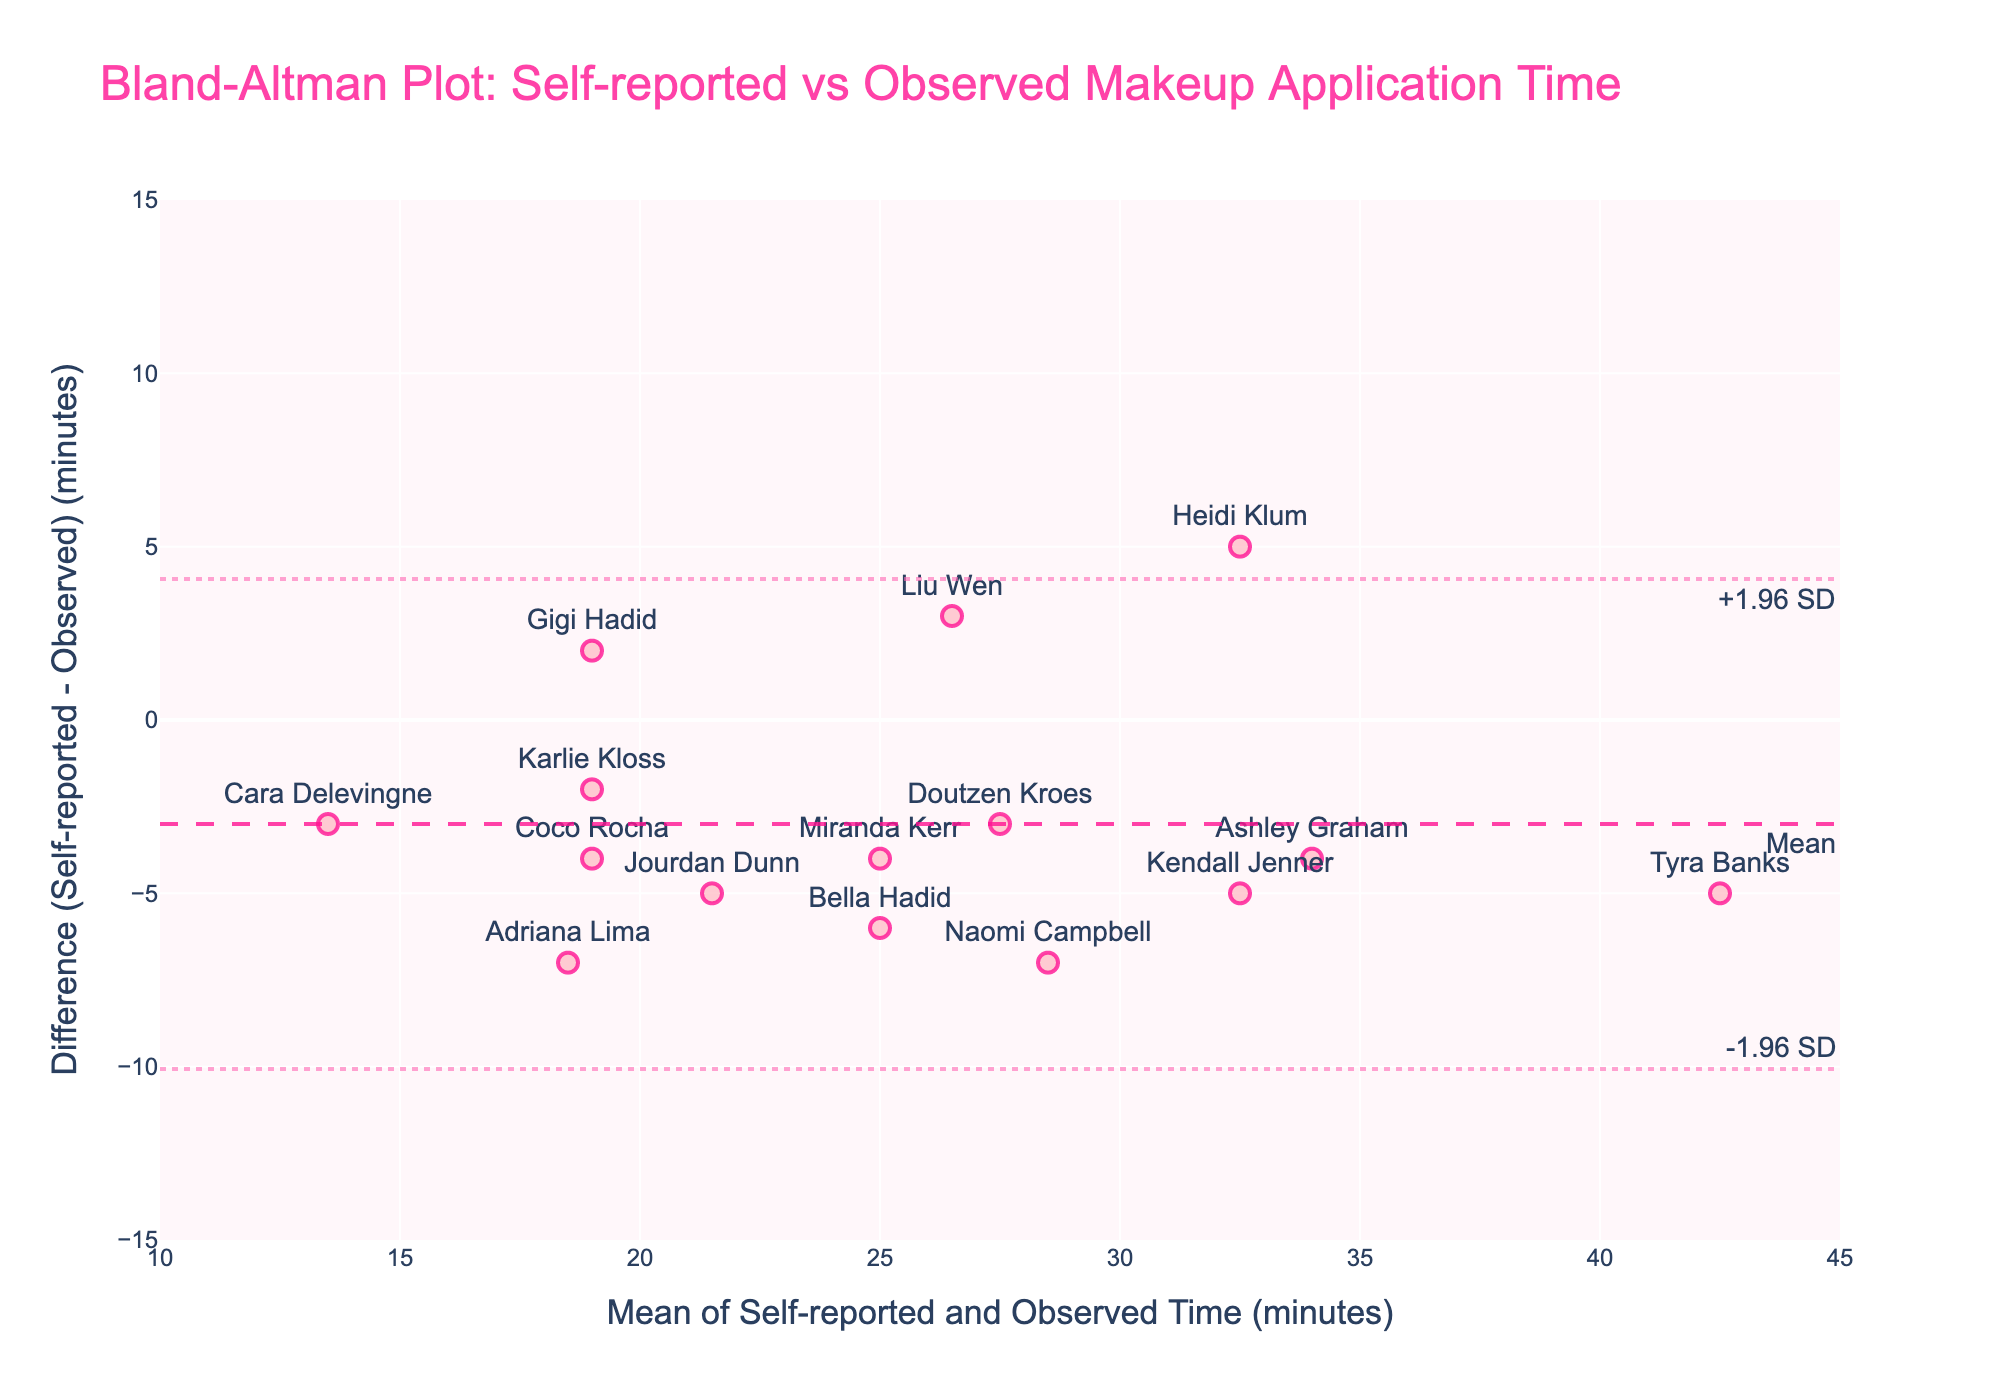What's the title of the plot? The title is located at the top of the plot and can be read directly.
Answer: Bland-Altman Plot: Self-reported vs Observed Makeup Application Time How are the data points visually represented in the plot? Observing the plot, the data points are represented as markers with text labels on top and are pinkish with a darker outline.
Answer: Markers with text labels What do the dashed and dotted horizontal lines represent? The horizontal lines are annotations in the plot: the dashed line represents the mean difference, and the dotted lines represent ±1.96 standard deviations (SD).
Answer: The dashed line represents the Mean, the dotted lines represent ±1.96 SD Which subject has the highest difference value, and what is the difference? By looking at the top-most marker, the subject with the largest positive difference (Self-reported - Observed) can be identified by its label.
Answer: Tyra Banks, with a difference of 5 What is the range of the x-axis values? The x-axis range can be determined by observing the scale provided at the bottom of the plot.
Answer: 10 to 45 minutes What is the mean difference between self-reported and observed times? The mean difference is indicated by the dashed horizontal line labeled 'Mean,' as noted with the annotated value.
Answer: Approximately -2.5 minutes Which subject has the smallest difference between self-reported and observed times? The subject closest to the Mean line labeled ‘Mean’ indicates the smallest difference in the plot.
Answer: Gigi Hadid, with a difference of 2 Are there more subjects who overestimated or underestimated their makeup application time? Observing the placement of data points above and below the Mean line helps identify the subjects who overestimated (points above the line) versus those who underestimated (points below the line).
Answer: More subjects overestimated their time What is the upper limit of agreement (Upper LoA) on the plot? The Upper LoA is represented by the upper dotted horizontal line with an annotation next to it.
Answer: 5.86 minutes Which two subjects had the exact same self-reported and observed mean makeup application time? Identifying the horizontal position where two subjects overlap exactly provides this information.
Answer: Liu Wen and Karlie Kloss (both around 23 minutes mean time) 